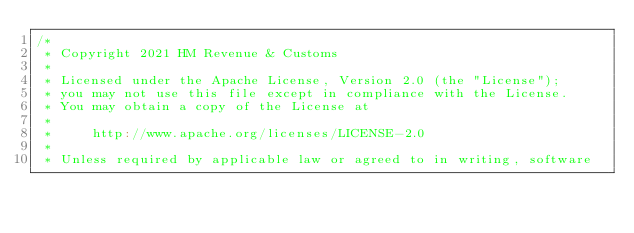<code> <loc_0><loc_0><loc_500><loc_500><_Scala_>/*
 * Copyright 2021 HM Revenue & Customs
 *
 * Licensed under the Apache License, Version 2.0 (the "License");
 * you may not use this file except in compliance with the License.
 * You may obtain a copy of the License at
 *
 *     http://www.apache.org/licenses/LICENSE-2.0
 *
 * Unless required by applicable law or agreed to in writing, software</code> 